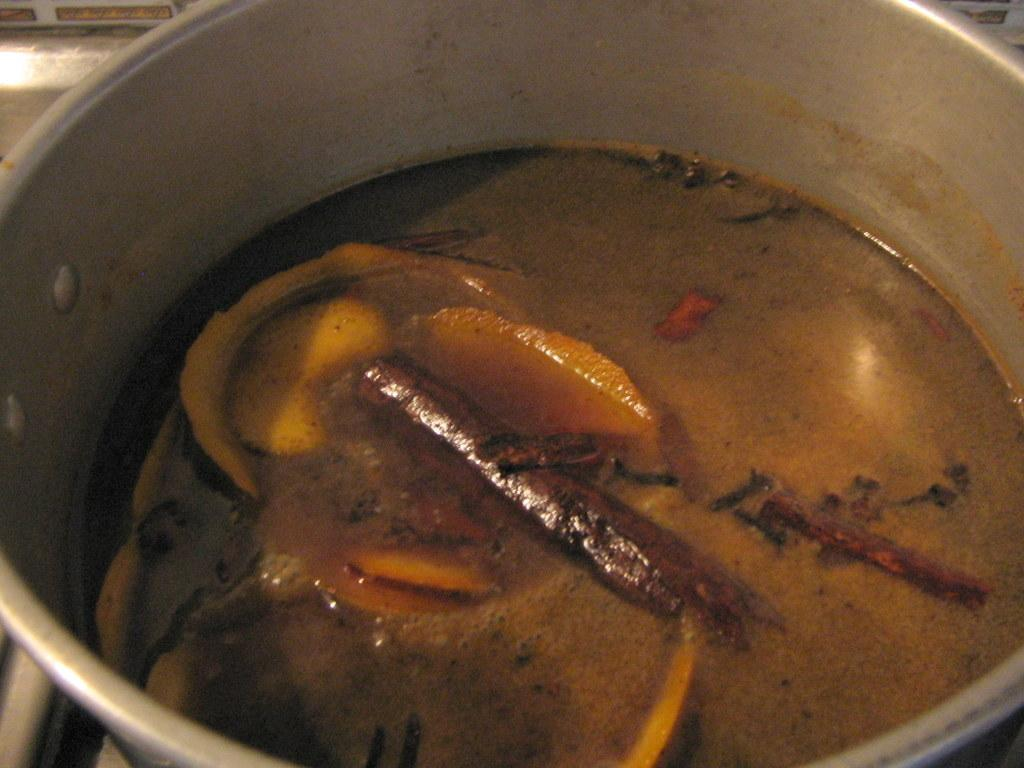What type of food can be seen in the image? The image contains food, but the specific type cannot be determined from the facts provided. What else is present in the bowl with the food? There is liquid in the bowl with the food. How are the food and liquid arranged in the image? Both the food and liquid are in a bowl. What scent can be detected from the wire in the image? There is no wire present in the image, so no scent can be detected from it. 